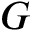<formula> <loc_0><loc_0><loc_500><loc_500>G</formula> 